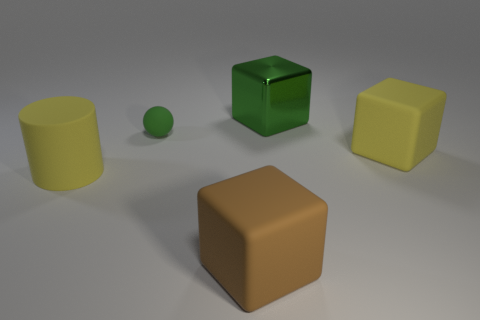Is there any other thing that is the same material as the big green cube?
Your answer should be compact. No. Is there anything else that has the same size as the sphere?
Keep it short and to the point. No. Is the number of green things less than the number of metal things?
Provide a succinct answer. No. There is a large yellow matte thing right of the metallic object; what is its shape?
Ensure brevity in your answer.  Cube. There is a matte cylinder; is it the same color as the large rubber cube behind the large rubber cylinder?
Offer a terse response. Yes. Are there the same number of yellow matte cylinders in front of the brown cube and yellow things that are to the right of the big yellow matte block?
Your answer should be very brief. Yes. How many other objects are the same size as the yellow block?
Ensure brevity in your answer.  3. What is the size of the matte ball?
Your answer should be compact. Small. Do the cylinder and the large object behind the ball have the same material?
Provide a succinct answer. No. Are there any brown objects of the same shape as the green shiny thing?
Provide a short and direct response. Yes. 